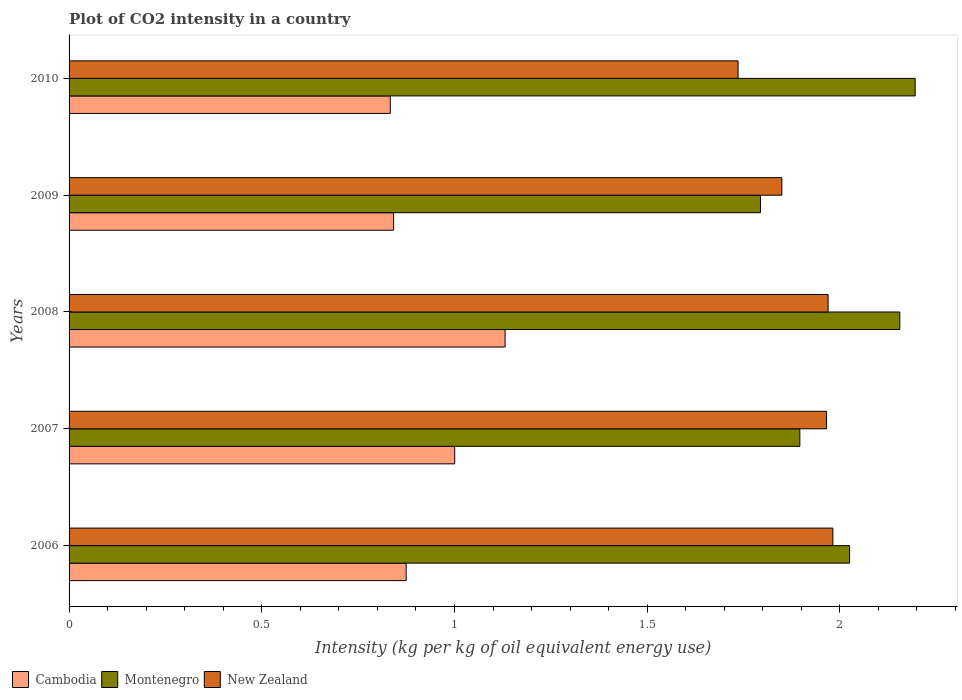How many different coloured bars are there?
Provide a short and direct response. 3. How many groups of bars are there?
Your answer should be compact. 5. Are the number of bars on each tick of the Y-axis equal?
Ensure brevity in your answer.  Yes. How many bars are there on the 5th tick from the top?
Your answer should be compact. 3. How many bars are there on the 4th tick from the bottom?
Keep it short and to the point. 3. What is the label of the 3rd group of bars from the top?
Your answer should be compact. 2008. What is the CO2 intensity in in Montenegro in 2006?
Provide a succinct answer. 2.03. Across all years, what is the maximum CO2 intensity in in New Zealand?
Ensure brevity in your answer.  1.98. Across all years, what is the minimum CO2 intensity in in Montenegro?
Give a very brief answer. 1.79. What is the total CO2 intensity in in New Zealand in the graph?
Ensure brevity in your answer.  9.5. What is the difference between the CO2 intensity in in Cambodia in 2007 and that in 2009?
Your answer should be compact. 0.16. What is the difference between the CO2 intensity in in Cambodia in 2006 and the CO2 intensity in in New Zealand in 2009?
Your answer should be compact. -0.97. What is the average CO2 intensity in in New Zealand per year?
Your answer should be compact. 1.9. In the year 2006, what is the difference between the CO2 intensity in in New Zealand and CO2 intensity in in Cambodia?
Provide a short and direct response. 1.11. What is the ratio of the CO2 intensity in in New Zealand in 2008 to that in 2010?
Ensure brevity in your answer.  1.13. Is the CO2 intensity in in Montenegro in 2006 less than that in 2009?
Your response must be concise. No. What is the difference between the highest and the second highest CO2 intensity in in Montenegro?
Give a very brief answer. 0.04. What is the difference between the highest and the lowest CO2 intensity in in New Zealand?
Give a very brief answer. 0.25. Is the sum of the CO2 intensity in in Montenegro in 2007 and 2008 greater than the maximum CO2 intensity in in Cambodia across all years?
Offer a very short reply. Yes. What does the 2nd bar from the top in 2009 represents?
Offer a terse response. Montenegro. What does the 3rd bar from the bottom in 2007 represents?
Make the answer very short. New Zealand. Is it the case that in every year, the sum of the CO2 intensity in in Montenegro and CO2 intensity in in Cambodia is greater than the CO2 intensity in in New Zealand?
Offer a very short reply. Yes. How many bars are there?
Offer a terse response. 15. Are all the bars in the graph horizontal?
Offer a very short reply. Yes. What is the difference between two consecutive major ticks on the X-axis?
Provide a short and direct response. 0.5. Where does the legend appear in the graph?
Your response must be concise. Bottom left. What is the title of the graph?
Ensure brevity in your answer.  Plot of CO2 intensity in a country. Does "Turks and Caicos Islands" appear as one of the legend labels in the graph?
Ensure brevity in your answer.  No. What is the label or title of the X-axis?
Provide a succinct answer. Intensity (kg per kg of oil equivalent energy use). What is the label or title of the Y-axis?
Your answer should be very brief. Years. What is the Intensity (kg per kg of oil equivalent energy use) of Cambodia in 2006?
Ensure brevity in your answer.  0.87. What is the Intensity (kg per kg of oil equivalent energy use) of Montenegro in 2006?
Provide a short and direct response. 2.03. What is the Intensity (kg per kg of oil equivalent energy use) in New Zealand in 2006?
Give a very brief answer. 1.98. What is the Intensity (kg per kg of oil equivalent energy use) of Cambodia in 2007?
Offer a terse response. 1. What is the Intensity (kg per kg of oil equivalent energy use) in Montenegro in 2007?
Offer a terse response. 1.9. What is the Intensity (kg per kg of oil equivalent energy use) in New Zealand in 2007?
Give a very brief answer. 1.97. What is the Intensity (kg per kg of oil equivalent energy use) in Cambodia in 2008?
Keep it short and to the point. 1.13. What is the Intensity (kg per kg of oil equivalent energy use) of Montenegro in 2008?
Make the answer very short. 2.16. What is the Intensity (kg per kg of oil equivalent energy use) in New Zealand in 2008?
Your answer should be compact. 1.97. What is the Intensity (kg per kg of oil equivalent energy use) in Cambodia in 2009?
Make the answer very short. 0.84. What is the Intensity (kg per kg of oil equivalent energy use) in Montenegro in 2009?
Ensure brevity in your answer.  1.79. What is the Intensity (kg per kg of oil equivalent energy use) in New Zealand in 2009?
Ensure brevity in your answer.  1.85. What is the Intensity (kg per kg of oil equivalent energy use) of Cambodia in 2010?
Your answer should be compact. 0.83. What is the Intensity (kg per kg of oil equivalent energy use) of Montenegro in 2010?
Offer a very short reply. 2.2. What is the Intensity (kg per kg of oil equivalent energy use) of New Zealand in 2010?
Keep it short and to the point. 1.74. Across all years, what is the maximum Intensity (kg per kg of oil equivalent energy use) of Cambodia?
Your response must be concise. 1.13. Across all years, what is the maximum Intensity (kg per kg of oil equivalent energy use) of Montenegro?
Your answer should be compact. 2.2. Across all years, what is the maximum Intensity (kg per kg of oil equivalent energy use) of New Zealand?
Offer a terse response. 1.98. Across all years, what is the minimum Intensity (kg per kg of oil equivalent energy use) of Cambodia?
Your response must be concise. 0.83. Across all years, what is the minimum Intensity (kg per kg of oil equivalent energy use) of Montenegro?
Ensure brevity in your answer.  1.79. Across all years, what is the minimum Intensity (kg per kg of oil equivalent energy use) in New Zealand?
Give a very brief answer. 1.74. What is the total Intensity (kg per kg of oil equivalent energy use) in Cambodia in the graph?
Your answer should be compact. 4.68. What is the total Intensity (kg per kg of oil equivalent energy use) of Montenegro in the graph?
Your answer should be compact. 10.07. What is the total Intensity (kg per kg of oil equivalent energy use) in New Zealand in the graph?
Ensure brevity in your answer.  9.5. What is the difference between the Intensity (kg per kg of oil equivalent energy use) in Cambodia in 2006 and that in 2007?
Your answer should be very brief. -0.13. What is the difference between the Intensity (kg per kg of oil equivalent energy use) in Montenegro in 2006 and that in 2007?
Keep it short and to the point. 0.13. What is the difference between the Intensity (kg per kg of oil equivalent energy use) of New Zealand in 2006 and that in 2007?
Provide a succinct answer. 0.02. What is the difference between the Intensity (kg per kg of oil equivalent energy use) of Cambodia in 2006 and that in 2008?
Offer a very short reply. -0.26. What is the difference between the Intensity (kg per kg of oil equivalent energy use) in Montenegro in 2006 and that in 2008?
Ensure brevity in your answer.  -0.13. What is the difference between the Intensity (kg per kg of oil equivalent energy use) in New Zealand in 2006 and that in 2008?
Your response must be concise. 0.01. What is the difference between the Intensity (kg per kg of oil equivalent energy use) of Cambodia in 2006 and that in 2009?
Give a very brief answer. 0.03. What is the difference between the Intensity (kg per kg of oil equivalent energy use) in Montenegro in 2006 and that in 2009?
Keep it short and to the point. 0.23. What is the difference between the Intensity (kg per kg of oil equivalent energy use) in New Zealand in 2006 and that in 2009?
Give a very brief answer. 0.13. What is the difference between the Intensity (kg per kg of oil equivalent energy use) of Cambodia in 2006 and that in 2010?
Provide a short and direct response. 0.04. What is the difference between the Intensity (kg per kg of oil equivalent energy use) of Montenegro in 2006 and that in 2010?
Your answer should be compact. -0.17. What is the difference between the Intensity (kg per kg of oil equivalent energy use) in New Zealand in 2006 and that in 2010?
Keep it short and to the point. 0.25. What is the difference between the Intensity (kg per kg of oil equivalent energy use) of Cambodia in 2007 and that in 2008?
Your response must be concise. -0.13. What is the difference between the Intensity (kg per kg of oil equivalent energy use) in Montenegro in 2007 and that in 2008?
Offer a very short reply. -0.26. What is the difference between the Intensity (kg per kg of oil equivalent energy use) of New Zealand in 2007 and that in 2008?
Offer a terse response. -0. What is the difference between the Intensity (kg per kg of oil equivalent energy use) in Cambodia in 2007 and that in 2009?
Your answer should be very brief. 0.16. What is the difference between the Intensity (kg per kg of oil equivalent energy use) in Montenegro in 2007 and that in 2009?
Provide a short and direct response. 0.1. What is the difference between the Intensity (kg per kg of oil equivalent energy use) in New Zealand in 2007 and that in 2009?
Your answer should be very brief. 0.12. What is the difference between the Intensity (kg per kg of oil equivalent energy use) in Cambodia in 2007 and that in 2010?
Offer a terse response. 0.17. What is the difference between the Intensity (kg per kg of oil equivalent energy use) of Montenegro in 2007 and that in 2010?
Your response must be concise. -0.3. What is the difference between the Intensity (kg per kg of oil equivalent energy use) of New Zealand in 2007 and that in 2010?
Your answer should be very brief. 0.23. What is the difference between the Intensity (kg per kg of oil equivalent energy use) in Cambodia in 2008 and that in 2009?
Keep it short and to the point. 0.29. What is the difference between the Intensity (kg per kg of oil equivalent energy use) in Montenegro in 2008 and that in 2009?
Ensure brevity in your answer.  0.36. What is the difference between the Intensity (kg per kg of oil equivalent energy use) in New Zealand in 2008 and that in 2009?
Give a very brief answer. 0.12. What is the difference between the Intensity (kg per kg of oil equivalent energy use) of Cambodia in 2008 and that in 2010?
Provide a short and direct response. 0.3. What is the difference between the Intensity (kg per kg of oil equivalent energy use) of Montenegro in 2008 and that in 2010?
Keep it short and to the point. -0.04. What is the difference between the Intensity (kg per kg of oil equivalent energy use) in New Zealand in 2008 and that in 2010?
Your answer should be compact. 0.23. What is the difference between the Intensity (kg per kg of oil equivalent energy use) of Cambodia in 2009 and that in 2010?
Offer a very short reply. 0.01. What is the difference between the Intensity (kg per kg of oil equivalent energy use) in Montenegro in 2009 and that in 2010?
Your response must be concise. -0.4. What is the difference between the Intensity (kg per kg of oil equivalent energy use) in New Zealand in 2009 and that in 2010?
Provide a short and direct response. 0.11. What is the difference between the Intensity (kg per kg of oil equivalent energy use) of Cambodia in 2006 and the Intensity (kg per kg of oil equivalent energy use) of Montenegro in 2007?
Offer a very short reply. -1.02. What is the difference between the Intensity (kg per kg of oil equivalent energy use) in Cambodia in 2006 and the Intensity (kg per kg of oil equivalent energy use) in New Zealand in 2007?
Give a very brief answer. -1.09. What is the difference between the Intensity (kg per kg of oil equivalent energy use) in Montenegro in 2006 and the Intensity (kg per kg of oil equivalent energy use) in New Zealand in 2007?
Ensure brevity in your answer.  0.06. What is the difference between the Intensity (kg per kg of oil equivalent energy use) in Cambodia in 2006 and the Intensity (kg per kg of oil equivalent energy use) in Montenegro in 2008?
Make the answer very short. -1.28. What is the difference between the Intensity (kg per kg of oil equivalent energy use) in Cambodia in 2006 and the Intensity (kg per kg of oil equivalent energy use) in New Zealand in 2008?
Your answer should be compact. -1.09. What is the difference between the Intensity (kg per kg of oil equivalent energy use) of Montenegro in 2006 and the Intensity (kg per kg of oil equivalent energy use) of New Zealand in 2008?
Make the answer very short. 0.06. What is the difference between the Intensity (kg per kg of oil equivalent energy use) in Cambodia in 2006 and the Intensity (kg per kg of oil equivalent energy use) in Montenegro in 2009?
Your response must be concise. -0.92. What is the difference between the Intensity (kg per kg of oil equivalent energy use) in Cambodia in 2006 and the Intensity (kg per kg of oil equivalent energy use) in New Zealand in 2009?
Your response must be concise. -0.97. What is the difference between the Intensity (kg per kg of oil equivalent energy use) in Montenegro in 2006 and the Intensity (kg per kg of oil equivalent energy use) in New Zealand in 2009?
Provide a short and direct response. 0.18. What is the difference between the Intensity (kg per kg of oil equivalent energy use) of Cambodia in 2006 and the Intensity (kg per kg of oil equivalent energy use) of Montenegro in 2010?
Offer a terse response. -1.32. What is the difference between the Intensity (kg per kg of oil equivalent energy use) of Cambodia in 2006 and the Intensity (kg per kg of oil equivalent energy use) of New Zealand in 2010?
Provide a succinct answer. -0.86. What is the difference between the Intensity (kg per kg of oil equivalent energy use) in Montenegro in 2006 and the Intensity (kg per kg of oil equivalent energy use) in New Zealand in 2010?
Offer a terse response. 0.29. What is the difference between the Intensity (kg per kg of oil equivalent energy use) of Cambodia in 2007 and the Intensity (kg per kg of oil equivalent energy use) of Montenegro in 2008?
Provide a short and direct response. -1.16. What is the difference between the Intensity (kg per kg of oil equivalent energy use) in Cambodia in 2007 and the Intensity (kg per kg of oil equivalent energy use) in New Zealand in 2008?
Provide a short and direct response. -0.97. What is the difference between the Intensity (kg per kg of oil equivalent energy use) in Montenegro in 2007 and the Intensity (kg per kg of oil equivalent energy use) in New Zealand in 2008?
Your response must be concise. -0.07. What is the difference between the Intensity (kg per kg of oil equivalent energy use) of Cambodia in 2007 and the Intensity (kg per kg of oil equivalent energy use) of Montenegro in 2009?
Your answer should be very brief. -0.79. What is the difference between the Intensity (kg per kg of oil equivalent energy use) in Cambodia in 2007 and the Intensity (kg per kg of oil equivalent energy use) in New Zealand in 2009?
Your answer should be very brief. -0.85. What is the difference between the Intensity (kg per kg of oil equivalent energy use) in Montenegro in 2007 and the Intensity (kg per kg of oil equivalent energy use) in New Zealand in 2009?
Provide a short and direct response. 0.05. What is the difference between the Intensity (kg per kg of oil equivalent energy use) of Cambodia in 2007 and the Intensity (kg per kg of oil equivalent energy use) of Montenegro in 2010?
Provide a short and direct response. -1.19. What is the difference between the Intensity (kg per kg of oil equivalent energy use) in Cambodia in 2007 and the Intensity (kg per kg of oil equivalent energy use) in New Zealand in 2010?
Offer a very short reply. -0.74. What is the difference between the Intensity (kg per kg of oil equivalent energy use) in Montenegro in 2007 and the Intensity (kg per kg of oil equivalent energy use) in New Zealand in 2010?
Provide a succinct answer. 0.16. What is the difference between the Intensity (kg per kg of oil equivalent energy use) in Cambodia in 2008 and the Intensity (kg per kg of oil equivalent energy use) in Montenegro in 2009?
Make the answer very short. -0.66. What is the difference between the Intensity (kg per kg of oil equivalent energy use) of Cambodia in 2008 and the Intensity (kg per kg of oil equivalent energy use) of New Zealand in 2009?
Make the answer very short. -0.72. What is the difference between the Intensity (kg per kg of oil equivalent energy use) in Montenegro in 2008 and the Intensity (kg per kg of oil equivalent energy use) in New Zealand in 2009?
Provide a succinct answer. 0.31. What is the difference between the Intensity (kg per kg of oil equivalent energy use) in Cambodia in 2008 and the Intensity (kg per kg of oil equivalent energy use) in Montenegro in 2010?
Your answer should be compact. -1.06. What is the difference between the Intensity (kg per kg of oil equivalent energy use) of Cambodia in 2008 and the Intensity (kg per kg of oil equivalent energy use) of New Zealand in 2010?
Provide a short and direct response. -0.6. What is the difference between the Intensity (kg per kg of oil equivalent energy use) of Montenegro in 2008 and the Intensity (kg per kg of oil equivalent energy use) of New Zealand in 2010?
Provide a succinct answer. 0.42. What is the difference between the Intensity (kg per kg of oil equivalent energy use) of Cambodia in 2009 and the Intensity (kg per kg of oil equivalent energy use) of Montenegro in 2010?
Keep it short and to the point. -1.35. What is the difference between the Intensity (kg per kg of oil equivalent energy use) in Cambodia in 2009 and the Intensity (kg per kg of oil equivalent energy use) in New Zealand in 2010?
Offer a very short reply. -0.89. What is the difference between the Intensity (kg per kg of oil equivalent energy use) in Montenegro in 2009 and the Intensity (kg per kg of oil equivalent energy use) in New Zealand in 2010?
Your answer should be compact. 0.06. What is the average Intensity (kg per kg of oil equivalent energy use) of Cambodia per year?
Provide a short and direct response. 0.94. What is the average Intensity (kg per kg of oil equivalent energy use) in Montenegro per year?
Provide a short and direct response. 2.01. What is the average Intensity (kg per kg of oil equivalent energy use) in New Zealand per year?
Provide a succinct answer. 1.9. In the year 2006, what is the difference between the Intensity (kg per kg of oil equivalent energy use) of Cambodia and Intensity (kg per kg of oil equivalent energy use) of Montenegro?
Your answer should be compact. -1.15. In the year 2006, what is the difference between the Intensity (kg per kg of oil equivalent energy use) in Cambodia and Intensity (kg per kg of oil equivalent energy use) in New Zealand?
Offer a very short reply. -1.11. In the year 2006, what is the difference between the Intensity (kg per kg of oil equivalent energy use) of Montenegro and Intensity (kg per kg of oil equivalent energy use) of New Zealand?
Your response must be concise. 0.04. In the year 2007, what is the difference between the Intensity (kg per kg of oil equivalent energy use) in Cambodia and Intensity (kg per kg of oil equivalent energy use) in Montenegro?
Your response must be concise. -0.9. In the year 2007, what is the difference between the Intensity (kg per kg of oil equivalent energy use) in Cambodia and Intensity (kg per kg of oil equivalent energy use) in New Zealand?
Provide a short and direct response. -0.96. In the year 2007, what is the difference between the Intensity (kg per kg of oil equivalent energy use) of Montenegro and Intensity (kg per kg of oil equivalent energy use) of New Zealand?
Offer a terse response. -0.07. In the year 2008, what is the difference between the Intensity (kg per kg of oil equivalent energy use) in Cambodia and Intensity (kg per kg of oil equivalent energy use) in Montenegro?
Offer a terse response. -1.02. In the year 2008, what is the difference between the Intensity (kg per kg of oil equivalent energy use) of Cambodia and Intensity (kg per kg of oil equivalent energy use) of New Zealand?
Your response must be concise. -0.84. In the year 2008, what is the difference between the Intensity (kg per kg of oil equivalent energy use) of Montenegro and Intensity (kg per kg of oil equivalent energy use) of New Zealand?
Your answer should be very brief. 0.19. In the year 2009, what is the difference between the Intensity (kg per kg of oil equivalent energy use) in Cambodia and Intensity (kg per kg of oil equivalent energy use) in Montenegro?
Ensure brevity in your answer.  -0.95. In the year 2009, what is the difference between the Intensity (kg per kg of oil equivalent energy use) in Cambodia and Intensity (kg per kg of oil equivalent energy use) in New Zealand?
Provide a short and direct response. -1.01. In the year 2009, what is the difference between the Intensity (kg per kg of oil equivalent energy use) of Montenegro and Intensity (kg per kg of oil equivalent energy use) of New Zealand?
Keep it short and to the point. -0.06. In the year 2010, what is the difference between the Intensity (kg per kg of oil equivalent energy use) in Cambodia and Intensity (kg per kg of oil equivalent energy use) in Montenegro?
Ensure brevity in your answer.  -1.36. In the year 2010, what is the difference between the Intensity (kg per kg of oil equivalent energy use) in Cambodia and Intensity (kg per kg of oil equivalent energy use) in New Zealand?
Provide a succinct answer. -0.9. In the year 2010, what is the difference between the Intensity (kg per kg of oil equivalent energy use) in Montenegro and Intensity (kg per kg of oil equivalent energy use) in New Zealand?
Make the answer very short. 0.46. What is the ratio of the Intensity (kg per kg of oil equivalent energy use) in Cambodia in 2006 to that in 2007?
Ensure brevity in your answer.  0.87. What is the ratio of the Intensity (kg per kg of oil equivalent energy use) of Montenegro in 2006 to that in 2007?
Provide a short and direct response. 1.07. What is the ratio of the Intensity (kg per kg of oil equivalent energy use) in New Zealand in 2006 to that in 2007?
Offer a terse response. 1.01. What is the ratio of the Intensity (kg per kg of oil equivalent energy use) of Cambodia in 2006 to that in 2008?
Ensure brevity in your answer.  0.77. What is the ratio of the Intensity (kg per kg of oil equivalent energy use) of Montenegro in 2006 to that in 2008?
Your response must be concise. 0.94. What is the ratio of the Intensity (kg per kg of oil equivalent energy use) in New Zealand in 2006 to that in 2008?
Keep it short and to the point. 1.01. What is the ratio of the Intensity (kg per kg of oil equivalent energy use) in Cambodia in 2006 to that in 2009?
Ensure brevity in your answer.  1.04. What is the ratio of the Intensity (kg per kg of oil equivalent energy use) in Montenegro in 2006 to that in 2009?
Offer a very short reply. 1.13. What is the ratio of the Intensity (kg per kg of oil equivalent energy use) of New Zealand in 2006 to that in 2009?
Provide a succinct answer. 1.07. What is the ratio of the Intensity (kg per kg of oil equivalent energy use) in Cambodia in 2006 to that in 2010?
Offer a terse response. 1.05. What is the ratio of the Intensity (kg per kg of oil equivalent energy use) in Montenegro in 2006 to that in 2010?
Offer a very short reply. 0.92. What is the ratio of the Intensity (kg per kg of oil equivalent energy use) in New Zealand in 2006 to that in 2010?
Your response must be concise. 1.14. What is the ratio of the Intensity (kg per kg of oil equivalent energy use) in Cambodia in 2007 to that in 2008?
Make the answer very short. 0.88. What is the ratio of the Intensity (kg per kg of oil equivalent energy use) of Montenegro in 2007 to that in 2008?
Your answer should be very brief. 0.88. What is the ratio of the Intensity (kg per kg of oil equivalent energy use) of Cambodia in 2007 to that in 2009?
Offer a terse response. 1.19. What is the ratio of the Intensity (kg per kg of oil equivalent energy use) of Montenegro in 2007 to that in 2009?
Ensure brevity in your answer.  1.06. What is the ratio of the Intensity (kg per kg of oil equivalent energy use) of New Zealand in 2007 to that in 2009?
Your answer should be compact. 1.06. What is the ratio of the Intensity (kg per kg of oil equivalent energy use) of Cambodia in 2007 to that in 2010?
Provide a short and direct response. 1.2. What is the ratio of the Intensity (kg per kg of oil equivalent energy use) of Montenegro in 2007 to that in 2010?
Make the answer very short. 0.86. What is the ratio of the Intensity (kg per kg of oil equivalent energy use) of New Zealand in 2007 to that in 2010?
Provide a succinct answer. 1.13. What is the ratio of the Intensity (kg per kg of oil equivalent energy use) in Cambodia in 2008 to that in 2009?
Give a very brief answer. 1.34. What is the ratio of the Intensity (kg per kg of oil equivalent energy use) of Montenegro in 2008 to that in 2009?
Your answer should be compact. 1.2. What is the ratio of the Intensity (kg per kg of oil equivalent energy use) in New Zealand in 2008 to that in 2009?
Offer a very short reply. 1.06. What is the ratio of the Intensity (kg per kg of oil equivalent energy use) of Cambodia in 2008 to that in 2010?
Your answer should be compact. 1.36. What is the ratio of the Intensity (kg per kg of oil equivalent energy use) of Montenegro in 2008 to that in 2010?
Your response must be concise. 0.98. What is the ratio of the Intensity (kg per kg of oil equivalent energy use) of New Zealand in 2008 to that in 2010?
Give a very brief answer. 1.13. What is the ratio of the Intensity (kg per kg of oil equivalent energy use) in Cambodia in 2009 to that in 2010?
Your response must be concise. 1.01. What is the ratio of the Intensity (kg per kg of oil equivalent energy use) in Montenegro in 2009 to that in 2010?
Your answer should be very brief. 0.82. What is the ratio of the Intensity (kg per kg of oil equivalent energy use) of New Zealand in 2009 to that in 2010?
Provide a short and direct response. 1.07. What is the difference between the highest and the second highest Intensity (kg per kg of oil equivalent energy use) in Cambodia?
Ensure brevity in your answer.  0.13. What is the difference between the highest and the second highest Intensity (kg per kg of oil equivalent energy use) in Montenegro?
Make the answer very short. 0.04. What is the difference between the highest and the second highest Intensity (kg per kg of oil equivalent energy use) in New Zealand?
Offer a terse response. 0.01. What is the difference between the highest and the lowest Intensity (kg per kg of oil equivalent energy use) in Cambodia?
Your answer should be compact. 0.3. What is the difference between the highest and the lowest Intensity (kg per kg of oil equivalent energy use) of Montenegro?
Make the answer very short. 0.4. What is the difference between the highest and the lowest Intensity (kg per kg of oil equivalent energy use) of New Zealand?
Provide a succinct answer. 0.25. 